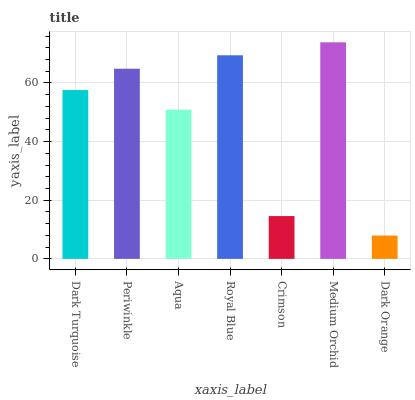Is Dark Orange the minimum?
Answer yes or no. Yes. Is Medium Orchid the maximum?
Answer yes or no. Yes. Is Periwinkle the minimum?
Answer yes or no. No. Is Periwinkle the maximum?
Answer yes or no. No. Is Periwinkle greater than Dark Turquoise?
Answer yes or no. Yes. Is Dark Turquoise less than Periwinkle?
Answer yes or no. Yes. Is Dark Turquoise greater than Periwinkle?
Answer yes or no. No. Is Periwinkle less than Dark Turquoise?
Answer yes or no. No. Is Dark Turquoise the high median?
Answer yes or no. Yes. Is Dark Turquoise the low median?
Answer yes or no. Yes. Is Medium Orchid the high median?
Answer yes or no. No. Is Dark Orange the low median?
Answer yes or no. No. 